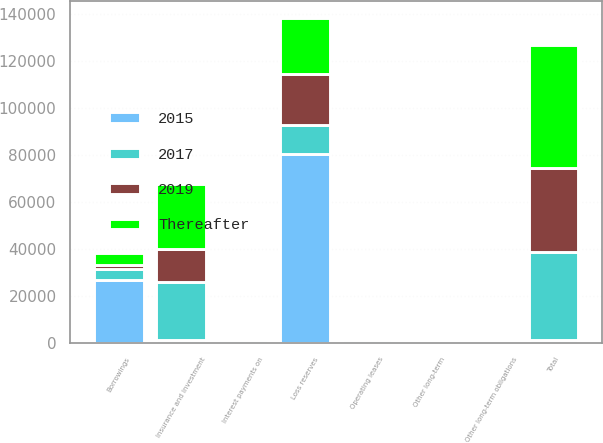Convert chart. <chart><loc_0><loc_0><loc_500><loc_500><stacked_bar_chart><ecel><fcel>Loss reserves<fcel>Insurance and investment<fcel>Interest payments on<fcel>Operating leases<fcel>Other long-term obligations<fcel>Total<fcel>Borrowings<fcel>Other long-term<nl><fcel>2015<fcel>80424<fcel>1299.5<fcel>1430<fcel>1169<fcel>23<fcel>1299.5<fcel>26656<fcel>257<nl><fcel>2019<fcel>21612<fcel>13870<fcel>64<fcel>308<fcel>6<fcel>35860<fcel>1980<fcel>6<nl><fcel>Thereafter<fcel>24154<fcel>27617<fcel>128<fcel>404<fcel>10<fcel>52313<fcel>5149<fcel>105<nl><fcel>2017<fcel>12248<fcel>24705<fcel>128<fcel>217<fcel>4<fcel>37302<fcel>4722<fcel>18<nl></chart> 